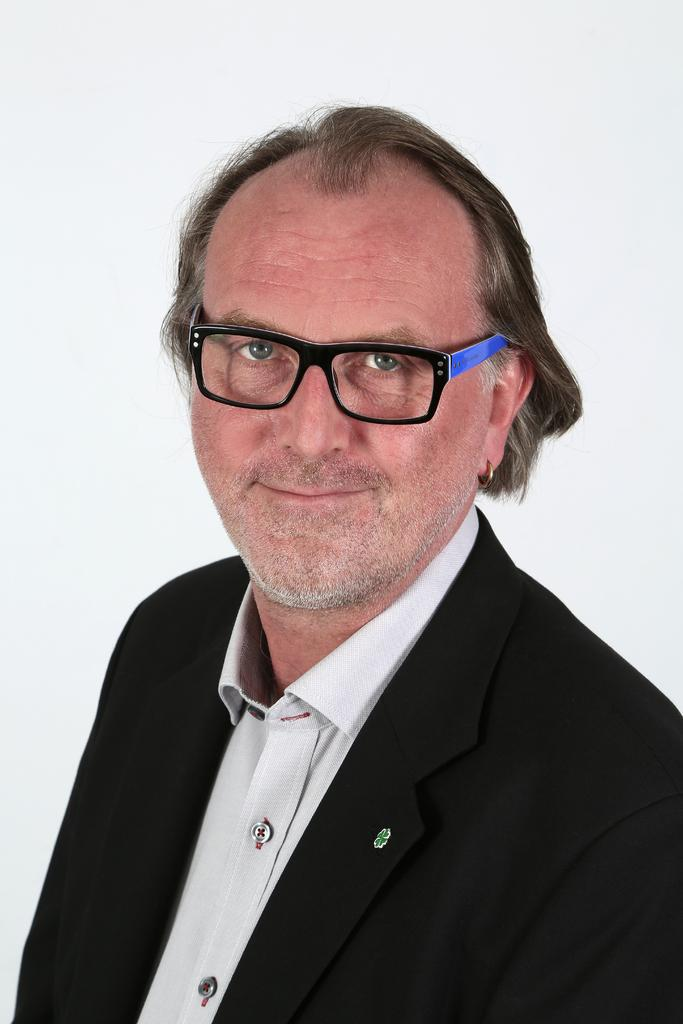What is the main subject of the image? There is a person in the image. What is the person wearing in the image? The person is wearing a black color suit. What accessory is the person wearing in the image? The person is wearing spectacles. What is the color of the background in the image? The background of the image is white. Can you see any roses in the image? There are no roses present in the image. Is there a stranger in the image? The image only features one person, so there is no stranger depicted. 